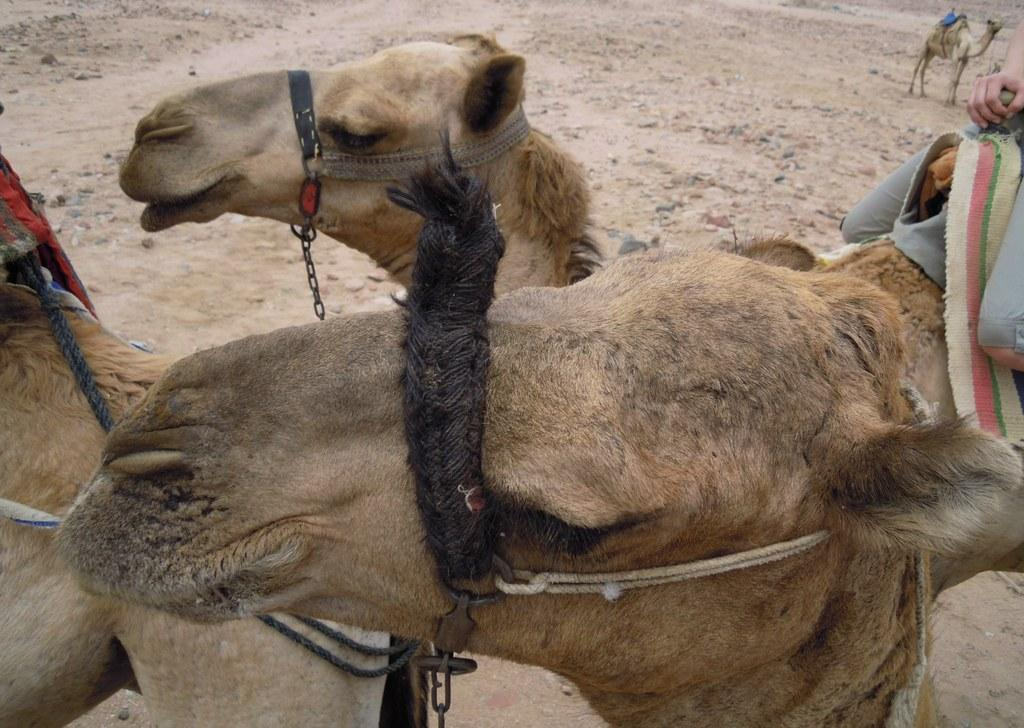What animals are present in the image? There are camels in the image. What type of terrain is visible in the image? There is sand in the image. How many eyes does the railway have in the image? There is no railway present in the image, so it is not possible to determine the number of eyes it might have. 